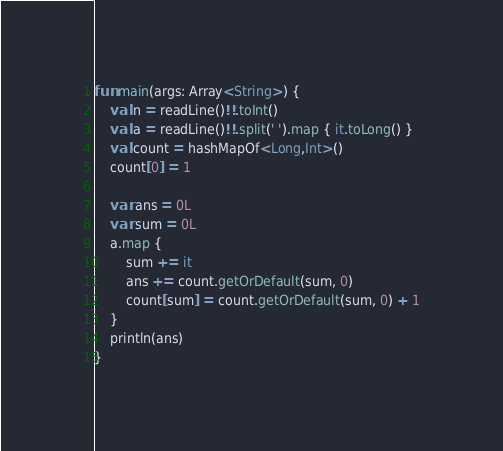<code> <loc_0><loc_0><loc_500><loc_500><_Kotlin_>fun main(args: Array<String>) {
    val n = readLine()!!.toInt()
    val a = readLine()!!.split(' ').map { it.toLong() }
    val count = hashMapOf<Long,Int>()
    count[0] = 1

    var ans = 0L
    var sum = 0L
    a.map {
        sum += it
        ans += count.getOrDefault(sum, 0)
        count[sum] = count.getOrDefault(sum, 0) + 1
    }
    println(ans)
}</code> 